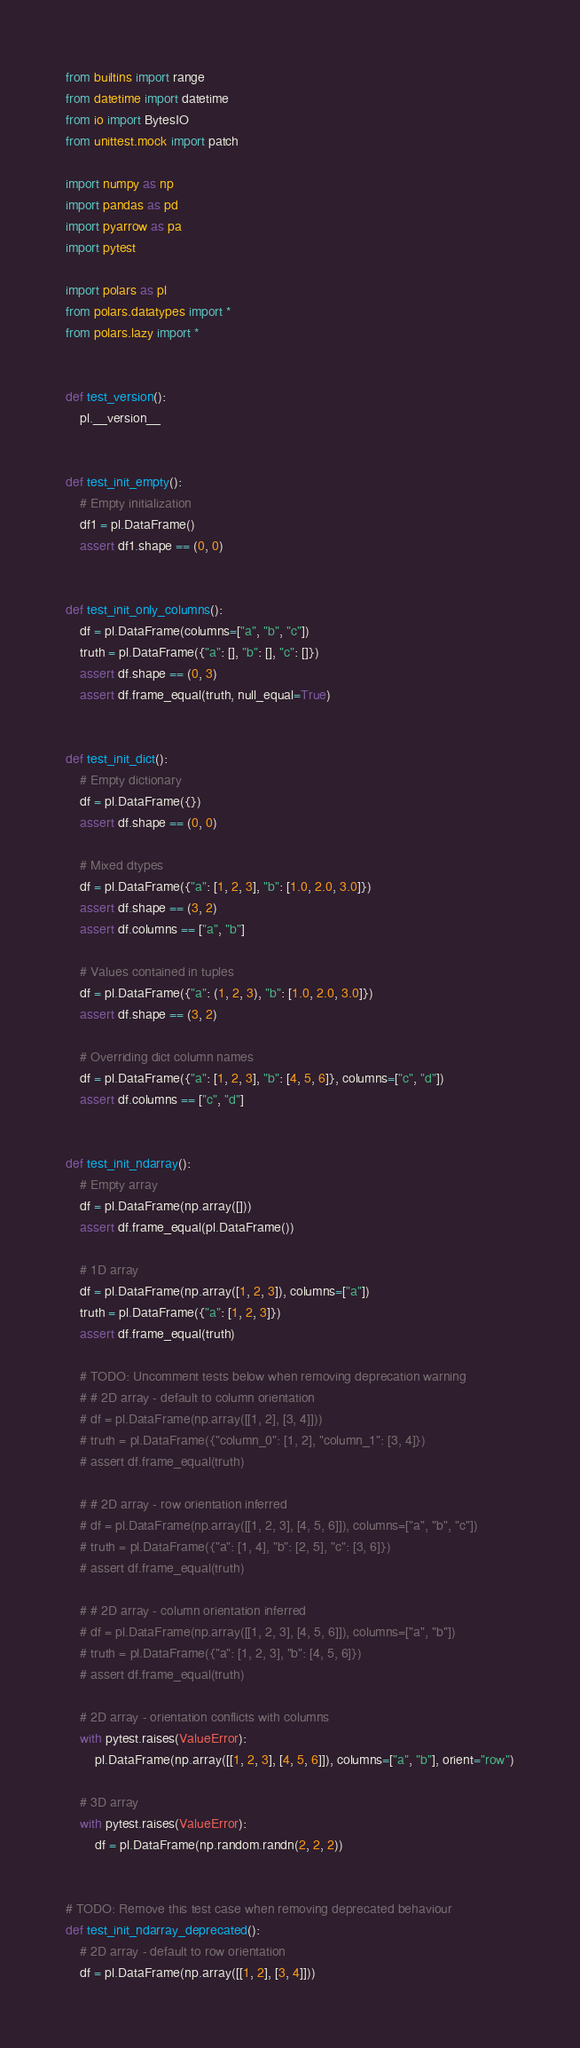<code> <loc_0><loc_0><loc_500><loc_500><_Python_>from builtins import range
from datetime import datetime
from io import BytesIO
from unittest.mock import patch

import numpy as np
import pandas as pd
import pyarrow as pa
import pytest

import polars as pl
from polars.datatypes import *
from polars.lazy import *


def test_version():
    pl.__version__


def test_init_empty():
    # Empty initialization
    df1 = pl.DataFrame()
    assert df1.shape == (0, 0)


def test_init_only_columns():
    df = pl.DataFrame(columns=["a", "b", "c"])
    truth = pl.DataFrame({"a": [], "b": [], "c": []})
    assert df.shape == (0, 3)
    assert df.frame_equal(truth, null_equal=True)


def test_init_dict():
    # Empty dictionary
    df = pl.DataFrame({})
    assert df.shape == (0, 0)

    # Mixed dtypes
    df = pl.DataFrame({"a": [1, 2, 3], "b": [1.0, 2.0, 3.0]})
    assert df.shape == (3, 2)
    assert df.columns == ["a", "b"]

    # Values contained in tuples
    df = pl.DataFrame({"a": (1, 2, 3), "b": [1.0, 2.0, 3.0]})
    assert df.shape == (3, 2)

    # Overriding dict column names
    df = pl.DataFrame({"a": [1, 2, 3], "b": [4, 5, 6]}, columns=["c", "d"])
    assert df.columns == ["c", "d"]


def test_init_ndarray():
    # Empty array
    df = pl.DataFrame(np.array([]))
    assert df.frame_equal(pl.DataFrame())

    # 1D array
    df = pl.DataFrame(np.array([1, 2, 3]), columns=["a"])
    truth = pl.DataFrame({"a": [1, 2, 3]})
    assert df.frame_equal(truth)

    # TODO: Uncomment tests below when removing deprecation warning
    # # 2D array - default to column orientation
    # df = pl.DataFrame(np.array([[1, 2], [3, 4]]))
    # truth = pl.DataFrame({"column_0": [1, 2], "column_1": [3, 4]})
    # assert df.frame_equal(truth)

    # # 2D array - row orientation inferred
    # df = pl.DataFrame(np.array([[1, 2, 3], [4, 5, 6]]), columns=["a", "b", "c"])
    # truth = pl.DataFrame({"a": [1, 4], "b": [2, 5], "c": [3, 6]})
    # assert df.frame_equal(truth)

    # # 2D array - column orientation inferred
    # df = pl.DataFrame(np.array([[1, 2, 3], [4, 5, 6]]), columns=["a", "b"])
    # truth = pl.DataFrame({"a": [1, 2, 3], "b": [4, 5, 6]})
    # assert df.frame_equal(truth)

    # 2D array - orientation conflicts with columns
    with pytest.raises(ValueError):
        pl.DataFrame(np.array([[1, 2, 3], [4, 5, 6]]), columns=["a", "b"], orient="row")

    # 3D array
    with pytest.raises(ValueError):
        df = pl.DataFrame(np.random.randn(2, 2, 2))


# TODO: Remove this test case when removing deprecated behaviour
def test_init_ndarray_deprecated():
    # 2D array - default to row orientation
    df = pl.DataFrame(np.array([[1, 2], [3, 4]]))</code> 